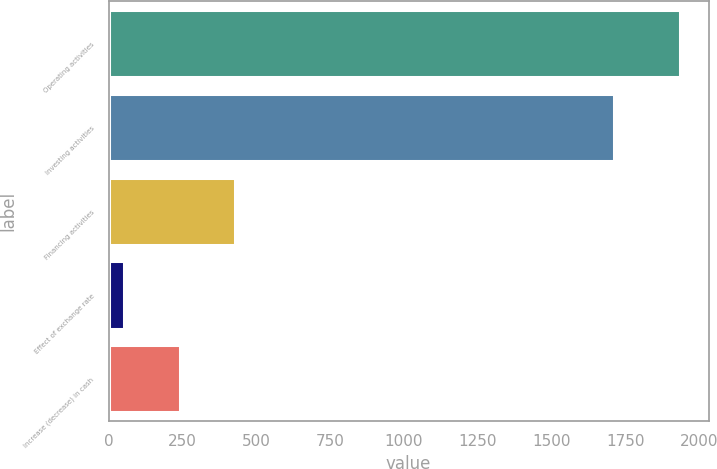Convert chart to OTSL. <chart><loc_0><loc_0><loc_500><loc_500><bar_chart><fcel>Operating activities<fcel>Investing activities<fcel>Financing activities<fcel>Effect of exchange rate<fcel>Increase (decrease) in cash<nl><fcel>1935<fcel>1712<fcel>428.6<fcel>52<fcel>240.3<nl></chart> 